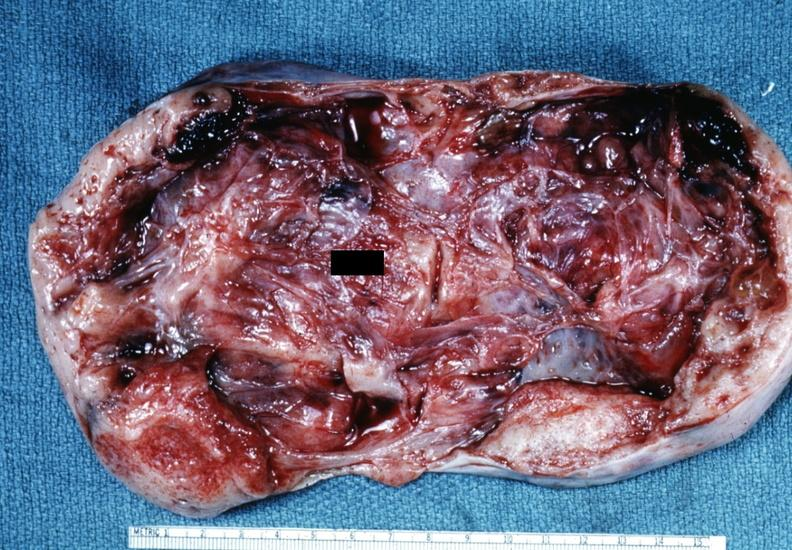s vasculature not diagnostic?
Answer the question using a single word or phrase. No 